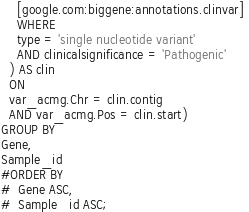<code> <loc_0><loc_0><loc_500><loc_500><_SQL_>    [google.com:biggene:annotations.clinvar] 
    WHERE
    type = 'single nucleotide variant'
    AND clinicalsignificance = 'Pathogenic'
  ) AS clin
  ON
  var_acmg.Chr = clin.contig
  AND var_acmg.Pos = clin.start)
GROUP BY
Gene,
Sample_id
#ORDER BY
#  Gene ASC,
#  Sample_id ASC;
</code> 